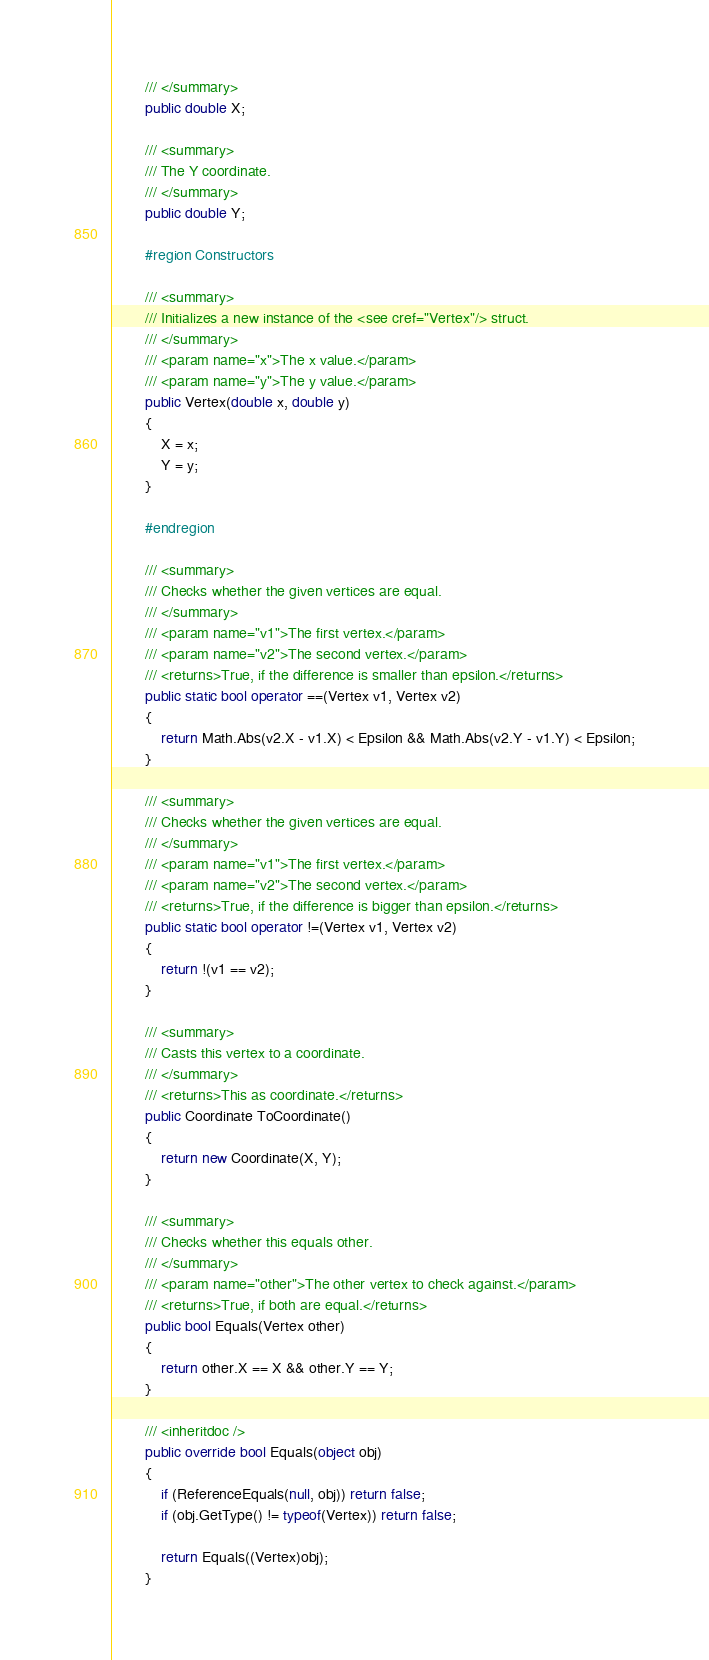<code> <loc_0><loc_0><loc_500><loc_500><_C#_>        /// </summary>
        public double X;

        /// <summary>
        /// The Y coordinate.
        /// </summary>
        public double Y;

        #region Constructors

        /// <summary>
        /// Initializes a new instance of the <see cref="Vertex"/> struct.
        /// </summary>
        /// <param name="x">The x value.</param>
        /// <param name="y">The y value.</param>
        public Vertex(double x, double y)
        {
            X = x;
            Y = y;
        }

        #endregion

        /// <summary>
        /// Checks whether the given vertices are equal.
        /// </summary>
        /// <param name="v1">The first vertex.</param>
        /// <param name="v2">The second vertex.</param>
        /// <returns>True, if the difference is smaller than epsilon.</returns>
        public static bool operator ==(Vertex v1, Vertex v2)
        {
            return Math.Abs(v2.X - v1.X) < Epsilon && Math.Abs(v2.Y - v1.Y) < Epsilon;
        }

        /// <summary>
        /// Checks whether the given vertices are equal.
        /// </summary>
        /// <param name="v1">The first vertex.</param>
        /// <param name="v2">The second vertex.</param>
        /// <returns>True, if the difference is bigger than epsilon.</returns>
        public static bool operator !=(Vertex v1, Vertex v2)
        {
            return !(v1 == v2);
        }

        /// <summary>
        /// Casts this vertex to a coordinate.
        /// </summary>
        /// <returns>This as coordinate.</returns>
        public Coordinate ToCoordinate()
        {
            return new Coordinate(X, Y);
        }

        /// <summary>
        /// Checks whether this equals other.
        /// </summary>
        /// <param name="other">The other vertex to check against.</param>
        /// <returns>True, if both are equal.</returns>
        public bool Equals(Vertex other)
        {
            return other.X == X && other.Y == Y;
        }

        /// <inheritdoc />
        public override bool Equals(object obj)
        {
            if (ReferenceEquals(null, obj)) return false;
            if (obj.GetType() != typeof(Vertex)) return false;

            return Equals((Vertex)obj);
        }
</code> 